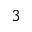<formula> <loc_0><loc_0><loc_500><loc_500>{ ^ { 3 } }</formula> 